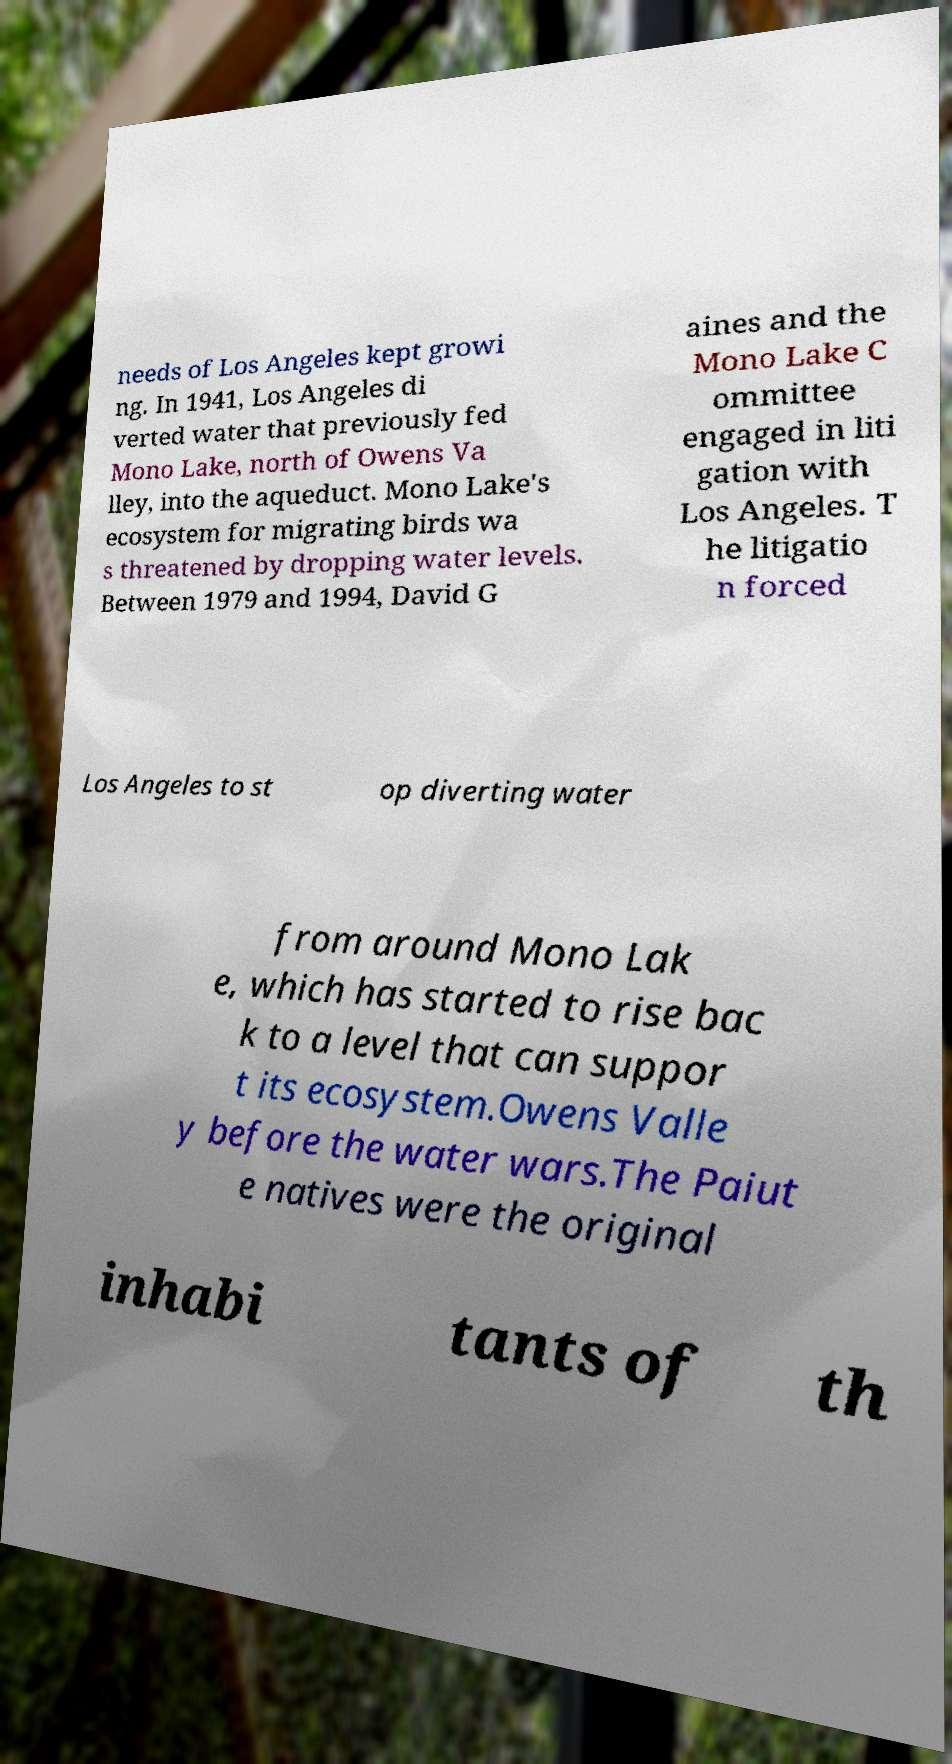Could you extract and type out the text from this image? needs of Los Angeles kept growi ng. In 1941, Los Angeles di verted water that previously fed Mono Lake, north of Owens Va lley, into the aqueduct. Mono Lake's ecosystem for migrating birds wa s threatened by dropping water levels. Between 1979 and 1994, David G aines and the Mono Lake C ommittee engaged in liti gation with Los Angeles. T he litigatio n forced Los Angeles to st op diverting water from around Mono Lak e, which has started to rise bac k to a level that can suppor t its ecosystem.Owens Valle y before the water wars.The Paiut e natives were the original inhabi tants of th 